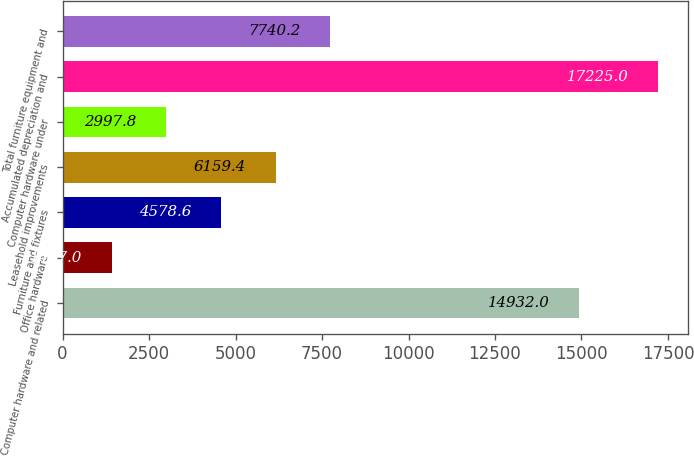Convert chart to OTSL. <chart><loc_0><loc_0><loc_500><loc_500><bar_chart><fcel>Computer hardware and related<fcel>Office hardware<fcel>Furniture and fixtures<fcel>Leasehold improvements<fcel>Computer hardware under<fcel>Accumulated depreciation and<fcel>Total furniture equipment and<nl><fcel>14932<fcel>1417<fcel>4578.6<fcel>6159.4<fcel>2997.8<fcel>17225<fcel>7740.2<nl></chart> 